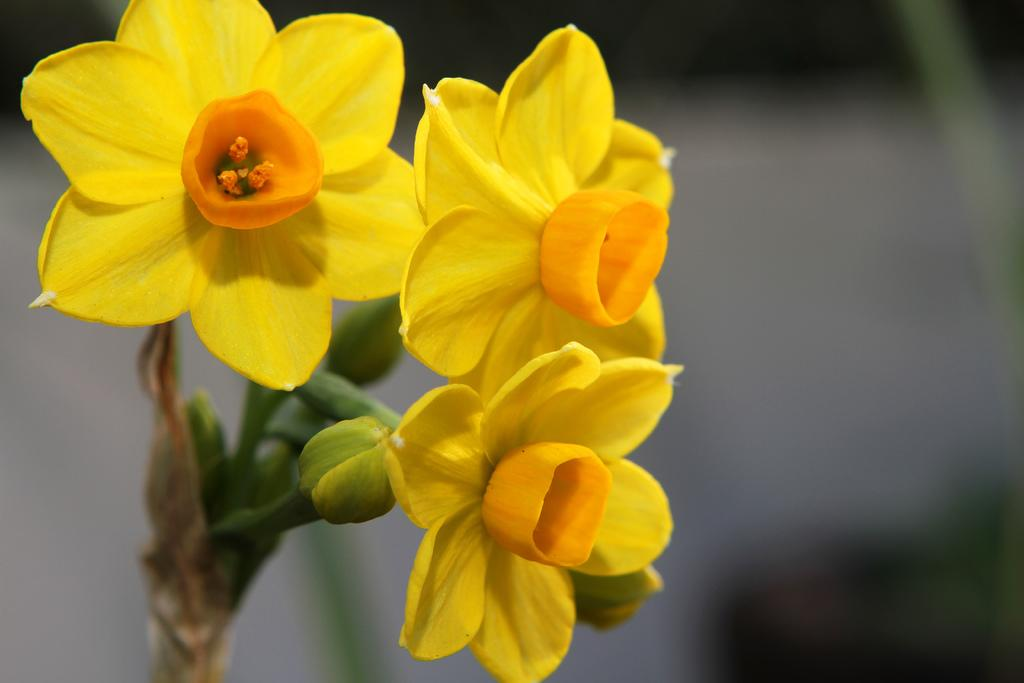What type of living organisms can be seen in the image? There are flowers in the image. How long does it take for the flowers to grow a minute in the image? The concept of time for the flowers to grow in the image is not applicable, as the image is a static representation and does not show the growth process. 